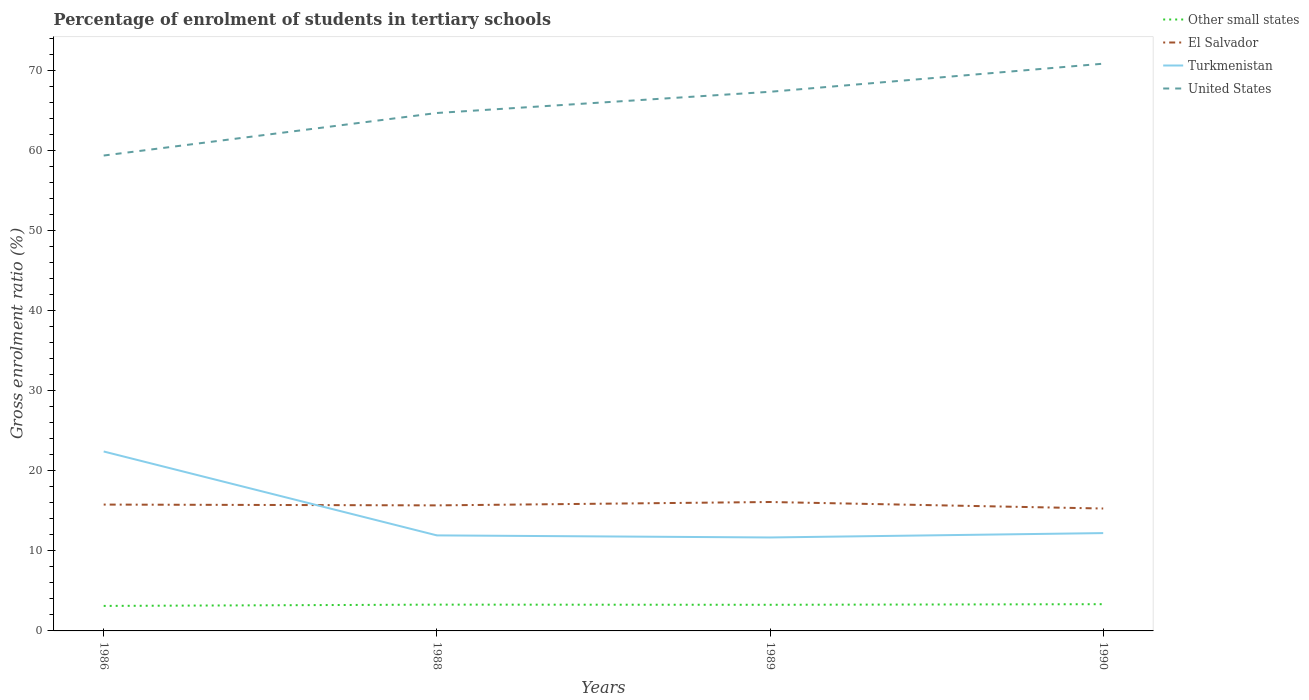Is the number of lines equal to the number of legend labels?
Make the answer very short. Yes. Across all years, what is the maximum percentage of students enrolled in tertiary schools in El Salvador?
Provide a short and direct response. 15.28. What is the total percentage of students enrolled in tertiary schools in Other small states in the graph?
Ensure brevity in your answer.  -0.22. What is the difference between the highest and the second highest percentage of students enrolled in tertiary schools in United States?
Make the answer very short. 11.46. Is the percentage of students enrolled in tertiary schools in Turkmenistan strictly greater than the percentage of students enrolled in tertiary schools in United States over the years?
Ensure brevity in your answer.  Yes. How many lines are there?
Offer a terse response. 4. What is the difference between two consecutive major ticks on the Y-axis?
Offer a terse response. 10. Does the graph contain any zero values?
Offer a very short reply. No. Where does the legend appear in the graph?
Ensure brevity in your answer.  Top right. How are the legend labels stacked?
Your response must be concise. Vertical. What is the title of the graph?
Make the answer very short. Percentage of enrolment of students in tertiary schools. What is the label or title of the X-axis?
Your answer should be compact. Years. What is the Gross enrolment ratio (%) of Other small states in 1986?
Provide a short and direct response. 3.12. What is the Gross enrolment ratio (%) of El Salvador in 1986?
Offer a very short reply. 15.77. What is the Gross enrolment ratio (%) in Turkmenistan in 1986?
Ensure brevity in your answer.  22.4. What is the Gross enrolment ratio (%) of United States in 1986?
Provide a succinct answer. 59.34. What is the Gross enrolment ratio (%) in Other small states in 1988?
Offer a terse response. 3.28. What is the Gross enrolment ratio (%) in El Salvador in 1988?
Provide a short and direct response. 15.67. What is the Gross enrolment ratio (%) in Turkmenistan in 1988?
Offer a terse response. 11.92. What is the Gross enrolment ratio (%) in United States in 1988?
Your response must be concise. 64.65. What is the Gross enrolment ratio (%) of Other small states in 1989?
Give a very brief answer. 3.26. What is the Gross enrolment ratio (%) in El Salvador in 1989?
Give a very brief answer. 16.09. What is the Gross enrolment ratio (%) in Turkmenistan in 1989?
Keep it short and to the point. 11.66. What is the Gross enrolment ratio (%) in United States in 1989?
Your response must be concise. 67.3. What is the Gross enrolment ratio (%) of Other small states in 1990?
Your answer should be compact. 3.34. What is the Gross enrolment ratio (%) in El Salvador in 1990?
Your answer should be very brief. 15.28. What is the Gross enrolment ratio (%) in Turkmenistan in 1990?
Offer a very short reply. 12.21. What is the Gross enrolment ratio (%) of United States in 1990?
Your answer should be very brief. 70.8. Across all years, what is the maximum Gross enrolment ratio (%) in Other small states?
Give a very brief answer. 3.34. Across all years, what is the maximum Gross enrolment ratio (%) of El Salvador?
Provide a succinct answer. 16.09. Across all years, what is the maximum Gross enrolment ratio (%) of Turkmenistan?
Offer a terse response. 22.4. Across all years, what is the maximum Gross enrolment ratio (%) in United States?
Ensure brevity in your answer.  70.8. Across all years, what is the minimum Gross enrolment ratio (%) of Other small states?
Provide a succinct answer. 3.12. Across all years, what is the minimum Gross enrolment ratio (%) of El Salvador?
Ensure brevity in your answer.  15.28. Across all years, what is the minimum Gross enrolment ratio (%) in Turkmenistan?
Keep it short and to the point. 11.66. Across all years, what is the minimum Gross enrolment ratio (%) in United States?
Keep it short and to the point. 59.34. What is the total Gross enrolment ratio (%) in Other small states in the graph?
Provide a short and direct response. 13. What is the total Gross enrolment ratio (%) of El Salvador in the graph?
Your response must be concise. 62.81. What is the total Gross enrolment ratio (%) in Turkmenistan in the graph?
Provide a succinct answer. 58.2. What is the total Gross enrolment ratio (%) in United States in the graph?
Your response must be concise. 262.09. What is the difference between the Gross enrolment ratio (%) in Other small states in 1986 and that in 1988?
Your answer should be compact. -0.16. What is the difference between the Gross enrolment ratio (%) of El Salvador in 1986 and that in 1988?
Offer a terse response. 0.1. What is the difference between the Gross enrolment ratio (%) in Turkmenistan in 1986 and that in 1988?
Provide a short and direct response. 10.47. What is the difference between the Gross enrolment ratio (%) in United States in 1986 and that in 1988?
Keep it short and to the point. -5.31. What is the difference between the Gross enrolment ratio (%) in Other small states in 1986 and that in 1989?
Your response must be concise. -0.14. What is the difference between the Gross enrolment ratio (%) of El Salvador in 1986 and that in 1989?
Make the answer very short. -0.32. What is the difference between the Gross enrolment ratio (%) in Turkmenistan in 1986 and that in 1989?
Your answer should be compact. 10.73. What is the difference between the Gross enrolment ratio (%) of United States in 1986 and that in 1989?
Your response must be concise. -7.96. What is the difference between the Gross enrolment ratio (%) of Other small states in 1986 and that in 1990?
Ensure brevity in your answer.  -0.22. What is the difference between the Gross enrolment ratio (%) in El Salvador in 1986 and that in 1990?
Make the answer very short. 0.49. What is the difference between the Gross enrolment ratio (%) in Turkmenistan in 1986 and that in 1990?
Provide a short and direct response. 10.19. What is the difference between the Gross enrolment ratio (%) of United States in 1986 and that in 1990?
Make the answer very short. -11.46. What is the difference between the Gross enrolment ratio (%) in Other small states in 1988 and that in 1989?
Ensure brevity in your answer.  0.02. What is the difference between the Gross enrolment ratio (%) of El Salvador in 1988 and that in 1989?
Your answer should be very brief. -0.42. What is the difference between the Gross enrolment ratio (%) in Turkmenistan in 1988 and that in 1989?
Your response must be concise. 0.26. What is the difference between the Gross enrolment ratio (%) in United States in 1988 and that in 1989?
Make the answer very short. -2.65. What is the difference between the Gross enrolment ratio (%) in Other small states in 1988 and that in 1990?
Provide a succinct answer. -0.06. What is the difference between the Gross enrolment ratio (%) of El Salvador in 1988 and that in 1990?
Offer a terse response. 0.39. What is the difference between the Gross enrolment ratio (%) in Turkmenistan in 1988 and that in 1990?
Your answer should be very brief. -0.29. What is the difference between the Gross enrolment ratio (%) in United States in 1988 and that in 1990?
Keep it short and to the point. -6.15. What is the difference between the Gross enrolment ratio (%) in Other small states in 1989 and that in 1990?
Offer a terse response. -0.08. What is the difference between the Gross enrolment ratio (%) of El Salvador in 1989 and that in 1990?
Your answer should be compact. 0.81. What is the difference between the Gross enrolment ratio (%) in Turkmenistan in 1989 and that in 1990?
Your answer should be very brief. -0.55. What is the difference between the Gross enrolment ratio (%) in United States in 1989 and that in 1990?
Your response must be concise. -3.51. What is the difference between the Gross enrolment ratio (%) of Other small states in 1986 and the Gross enrolment ratio (%) of El Salvador in 1988?
Provide a succinct answer. -12.55. What is the difference between the Gross enrolment ratio (%) of Other small states in 1986 and the Gross enrolment ratio (%) of Turkmenistan in 1988?
Ensure brevity in your answer.  -8.8. What is the difference between the Gross enrolment ratio (%) in Other small states in 1986 and the Gross enrolment ratio (%) in United States in 1988?
Your response must be concise. -61.53. What is the difference between the Gross enrolment ratio (%) in El Salvador in 1986 and the Gross enrolment ratio (%) in Turkmenistan in 1988?
Provide a short and direct response. 3.85. What is the difference between the Gross enrolment ratio (%) in El Salvador in 1986 and the Gross enrolment ratio (%) in United States in 1988?
Offer a terse response. -48.88. What is the difference between the Gross enrolment ratio (%) in Turkmenistan in 1986 and the Gross enrolment ratio (%) in United States in 1988?
Ensure brevity in your answer.  -42.25. What is the difference between the Gross enrolment ratio (%) in Other small states in 1986 and the Gross enrolment ratio (%) in El Salvador in 1989?
Ensure brevity in your answer.  -12.97. What is the difference between the Gross enrolment ratio (%) of Other small states in 1986 and the Gross enrolment ratio (%) of Turkmenistan in 1989?
Your response must be concise. -8.54. What is the difference between the Gross enrolment ratio (%) in Other small states in 1986 and the Gross enrolment ratio (%) in United States in 1989?
Your response must be concise. -64.18. What is the difference between the Gross enrolment ratio (%) in El Salvador in 1986 and the Gross enrolment ratio (%) in Turkmenistan in 1989?
Offer a very short reply. 4.11. What is the difference between the Gross enrolment ratio (%) in El Salvador in 1986 and the Gross enrolment ratio (%) in United States in 1989?
Offer a very short reply. -51.53. What is the difference between the Gross enrolment ratio (%) in Turkmenistan in 1986 and the Gross enrolment ratio (%) in United States in 1989?
Ensure brevity in your answer.  -44.9. What is the difference between the Gross enrolment ratio (%) of Other small states in 1986 and the Gross enrolment ratio (%) of El Salvador in 1990?
Offer a terse response. -12.16. What is the difference between the Gross enrolment ratio (%) in Other small states in 1986 and the Gross enrolment ratio (%) in Turkmenistan in 1990?
Your response must be concise. -9.09. What is the difference between the Gross enrolment ratio (%) of Other small states in 1986 and the Gross enrolment ratio (%) of United States in 1990?
Provide a succinct answer. -67.68. What is the difference between the Gross enrolment ratio (%) of El Salvador in 1986 and the Gross enrolment ratio (%) of Turkmenistan in 1990?
Offer a terse response. 3.56. What is the difference between the Gross enrolment ratio (%) of El Salvador in 1986 and the Gross enrolment ratio (%) of United States in 1990?
Ensure brevity in your answer.  -55.03. What is the difference between the Gross enrolment ratio (%) of Turkmenistan in 1986 and the Gross enrolment ratio (%) of United States in 1990?
Give a very brief answer. -48.41. What is the difference between the Gross enrolment ratio (%) in Other small states in 1988 and the Gross enrolment ratio (%) in El Salvador in 1989?
Your response must be concise. -12.81. What is the difference between the Gross enrolment ratio (%) in Other small states in 1988 and the Gross enrolment ratio (%) in Turkmenistan in 1989?
Provide a short and direct response. -8.38. What is the difference between the Gross enrolment ratio (%) of Other small states in 1988 and the Gross enrolment ratio (%) of United States in 1989?
Your response must be concise. -64.02. What is the difference between the Gross enrolment ratio (%) in El Salvador in 1988 and the Gross enrolment ratio (%) in Turkmenistan in 1989?
Your response must be concise. 4.01. What is the difference between the Gross enrolment ratio (%) in El Salvador in 1988 and the Gross enrolment ratio (%) in United States in 1989?
Offer a very short reply. -51.63. What is the difference between the Gross enrolment ratio (%) of Turkmenistan in 1988 and the Gross enrolment ratio (%) of United States in 1989?
Give a very brief answer. -55.37. What is the difference between the Gross enrolment ratio (%) in Other small states in 1988 and the Gross enrolment ratio (%) in El Salvador in 1990?
Your answer should be very brief. -12. What is the difference between the Gross enrolment ratio (%) in Other small states in 1988 and the Gross enrolment ratio (%) in Turkmenistan in 1990?
Your answer should be compact. -8.93. What is the difference between the Gross enrolment ratio (%) in Other small states in 1988 and the Gross enrolment ratio (%) in United States in 1990?
Keep it short and to the point. -67.52. What is the difference between the Gross enrolment ratio (%) in El Salvador in 1988 and the Gross enrolment ratio (%) in Turkmenistan in 1990?
Offer a terse response. 3.46. What is the difference between the Gross enrolment ratio (%) in El Salvador in 1988 and the Gross enrolment ratio (%) in United States in 1990?
Your response must be concise. -55.13. What is the difference between the Gross enrolment ratio (%) in Turkmenistan in 1988 and the Gross enrolment ratio (%) in United States in 1990?
Give a very brief answer. -58.88. What is the difference between the Gross enrolment ratio (%) in Other small states in 1989 and the Gross enrolment ratio (%) in El Salvador in 1990?
Provide a succinct answer. -12.02. What is the difference between the Gross enrolment ratio (%) of Other small states in 1989 and the Gross enrolment ratio (%) of Turkmenistan in 1990?
Your answer should be compact. -8.95. What is the difference between the Gross enrolment ratio (%) in Other small states in 1989 and the Gross enrolment ratio (%) in United States in 1990?
Your answer should be compact. -67.54. What is the difference between the Gross enrolment ratio (%) of El Salvador in 1989 and the Gross enrolment ratio (%) of Turkmenistan in 1990?
Offer a terse response. 3.88. What is the difference between the Gross enrolment ratio (%) of El Salvador in 1989 and the Gross enrolment ratio (%) of United States in 1990?
Make the answer very short. -54.71. What is the difference between the Gross enrolment ratio (%) in Turkmenistan in 1989 and the Gross enrolment ratio (%) in United States in 1990?
Keep it short and to the point. -59.14. What is the average Gross enrolment ratio (%) in Other small states per year?
Keep it short and to the point. 3.25. What is the average Gross enrolment ratio (%) in El Salvador per year?
Keep it short and to the point. 15.7. What is the average Gross enrolment ratio (%) in Turkmenistan per year?
Your answer should be very brief. 14.55. What is the average Gross enrolment ratio (%) of United States per year?
Ensure brevity in your answer.  65.52. In the year 1986, what is the difference between the Gross enrolment ratio (%) of Other small states and Gross enrolment ratio (%) of El Salvador?
Provide a short and direct response. -12.65. In the year 1986, what is the difference between the Gross enrolment ratio (%) in Other small states and Gross enrolment ratio (%) in Turkmenistan?
Your response must be concise. -19.28. In the year 1986, what is the difference between the Gross enrolment ratio (%) in Other small states and Gross enrolment ratio (%) in United States?
Make the answer very short. -56.22. In the year 1986, what is the difference between the Gross enrolment ratio (%) of El Salvador and Gross enrolment ratio (%) of Turkmenistan?
Provide a short and direct response. -6.63. In the year 1986, what is the difference between the Gross enrolment ratio (%) of El Salvador and Gross enrolment ratio (%) of United States?
Your answer should be compact. -43.57. In the year 1986, what is the difference between the Gross enrolment ratio (%) in Turkmenistan and Gross enrolment ratio (%) in United States?
Provide a succinct answer. -36.94. In the year 1988, what is the difference between the Gross enrolment ratio (%) of Other small states and Gross enrolment ratio (%) of El Salvador?
Give a very brief answer. -12.39. In the year 1988, what is the difference between the Gross enrolment ratio (%) of Other small states and Gross enrolment ratio (%) of Turkmenistan?
Make the answer very short. -8.64. In the year 1988, what is the difference between the Gross enrolment ratio (%) in Other small states and Gross enrolment ratio (%) in United States?
Offer a terse response. -61.37. In the year 1988, what is the difference between the Gross enrolment ratio (%) in El Salvador and Gross enrolment ratio (%) in Turkmenistan?
Provide a succinct answer. 3.75. In the year 1988, what is the difference between the Gross enrolment ratio (%) of El Salvador and Gross enrolment ratio (%) of United States?
Your answer should be very brief. -48.98. In the year 1988, what is the difference between the Gross enrolment ratio (%) of Turkmenistan and Gross enrolment ratio (%) of United States?
Provide a short and direct response. -52.73. In the year 1989, what is the difference between the Gross enrolment ratio (%) of Other small states and Gross enrolment ratio (%) of El Salvador?
Your answer should be very brief. -12.83. In the year 1989, what is the difference between the Gross enrolment ratio (%) of Other small states and Gross enrolment ratio (%) of Turkmenistan?
Your response must be concise. -8.4. In the year 1989, what is the difference between the Gross enrolment ratio (%) of Other small states and Gross enrolment ratio (%) of United States?
Keep it short and to the point. -64.04. In the year 1989, what is the difference between the Gross enrolment ratio (%) of El Salvador and Gross enrolment ratio (%) of Turkmenistan?
Your answer should be compact. 4.43. In the year 1989, what is the difference between the Gross enrolment ratio (%) of El Salvador and Gross enrolment ratio (%) of United States?
Provide a short and direct response. -51.21. In the year 1989, what is the difference between the Gross enrolment ratio (%) in Turkmenistan and Gross enrolment ratio (%) in United States?
Ensure brevity in your answer.  -55.63. In the year 1990, what is the difference between the Gross enrolment ratio (%) in Other small states and Gross enrolment ratio (%) in El Salvador?
Your answer should be very brief. -11.94. In the year 1990, what is the difference between the Gross enrolment ratio (%) in Other small states and Gross enrolment ratio (%) in Turkmenistan?
Provide a succinct answer. -8.88. In the year 1990, what is the difference between the Gross enrolment ratio (%) of Other small states and Gross enrolment ratio (%) of United States?
Offer a very short reply. -67.47. In the year 1990, what is the difference between the Gross enrolment ratio (%) of El Salvador and Gross enrolment ratio (%) of Turkmenistan?
Provide a succinct answer. 3.07. In the year 1990, what is the difference between the Gross enrolment ratio (%) in El Salvador and Gross enrolment ratio (%) in United States?
Provide a short and direct response. -55.53. In the year 1990, what is the difference between the Gross enrolment ratio (%) in Turkmenistan and Gross enrolment ratio (%) in United States?
Keep it short and to the point. -58.59. What is the ratio of the Gross enrolment ratio (%) in Other small states in 1986 to that in 1988?
Ensure brevity in your answer.  0.95. What is the ratio of the Gross enrolment ratio (%) of El Salvador in 1986 to that in 1988?
Your response must be concise. 1.01. What is the ratio of the Gross enrolment ratio (%) of Turkmenistan in 1986 to that in 1988?
Offer a very short reply. 1.88. What is the ratio of the Gross enrolment ratio (%) of United States in 1986 to that in 1988?
Offer a very short reply. 0.92. What is the ratio of the Gross enrolment ratio (%) of Other small states in 1986 to that in 1989?
Your answer should be very brief. 0.96. What is the ratio of the Gross enrolment ratio (%) of El Salvador in 1986 to that in 1989?
Ensure brevity in your answer.  0.98. What is the ratio of the Gross enrolment ratio (%) in Turkmenistan in 1986 to that in 1989?
Your response must be concise. 1.92. What is the ratio of the Gross enrolment ratio (%) of United States in 1986 to that in 1989?
Your answer should be very brief. 0.88. What is the ratio of the Gross enrolment ratio (%) of Other small states in 1986 to that in 1990?
Provide a short and direct response. 0.94. What is the ratio of the Gross enrolment ratio (%) in El Salvador in 1986 to that in 1990?
Offer a very short reply. 1.03. What is the ratio of the Gross enrolment ratio (%) in Turkmenistan in 1986 to that in 1990?
Ensure brevity in your answer.  1.83. What is the ratio of the Gross enrolment ratio (%) in United States in 1986 to that in 1990?
Provide a short and direct response. 0.84. What is the ratio of the Gross enrolment ratio (%) of El Salvador in 1988 to that in 1989?
Provide a succinct answer. 0.97. What is the ratio of the Gross enrolment ratio (%) of Turkmenistan in 1988 to that in 1989?
Provide a short and direct response. 1.02. What is the ratio of the Gross enrolment ratio (%) of United States in 1988 to that in 1989?
Offer a very short reply. 0.96. What is the ratio of the Gross enrolment ratio (%) of Other small states in 1988 to that in 1990?
Your response must be concise. 0.98. What is the ratio of the Gross enrolment ratio (%) in El Salvador in 1988 to that in 1990?
Keep it short and to the point. 1.03. What is the ratio of the Gross enrolment ratio (%) in Turkmenistan in 1988 to that in 1990?
Provide a short and direct response. 0.98. What is the ratio of the Gross enrolment ratio (%) in United States in 1988 to that in 1990?
Your response must be concise. 0.91. What is the ratio of the Gross enrolment ratio (%) in Other small states in 1989 to that in 1990?
Your answer should be very brief. 0.98. What is the ratio of the Gross enrolment ratio (%) of El Salvador in 1989 to that in 1990?
Offer a very short reply. 1.05. What is the ratio of the Gross enrolment ratio (%) of Turkmenistan in 1989 to that in 1990?
Make the answer very short. 0.96. What is the ratio of the Gross enrolment ratio (%) in United States in 1989 to that in 1990?
Ensure brevity in your answer.  0.95. What is the difference between the highest and the second highest Gross enrolment ratio (%) of Other small states?
Provide a succinct answer. 0.06. What is the difference between the highest and the second highest Gross enrolment ratio (%) of El Salvador?
Provide a succinct answer. 0.32. What is the difference between the highest and the second highest Gross enrolment ratio (%) of Turkmenistan?
Your answer should be very brief. 10.19. What is the difference between the highest and the second highest Gross enrolment ratio (%) of United States?
Give a very brief answer. 3.51. What is the difference between the highest and the lowest Gross enrolment ratio (%) of Other small states?
Make the answer very short. 0.22. What is the difference between the highest and the lowest Gross enrolment ratio (%) in El Salvador?
Your answer should be compact. 0.81. What is the difference between the highest and the lowest Gross enrolment ratio (%) of Turkmenistan?
Provide a succinct answer. 10.73. What is the difference between the highest and the lowest Gross enrolment ratio (%) of United States?
Offer a terse response. 11.46. 